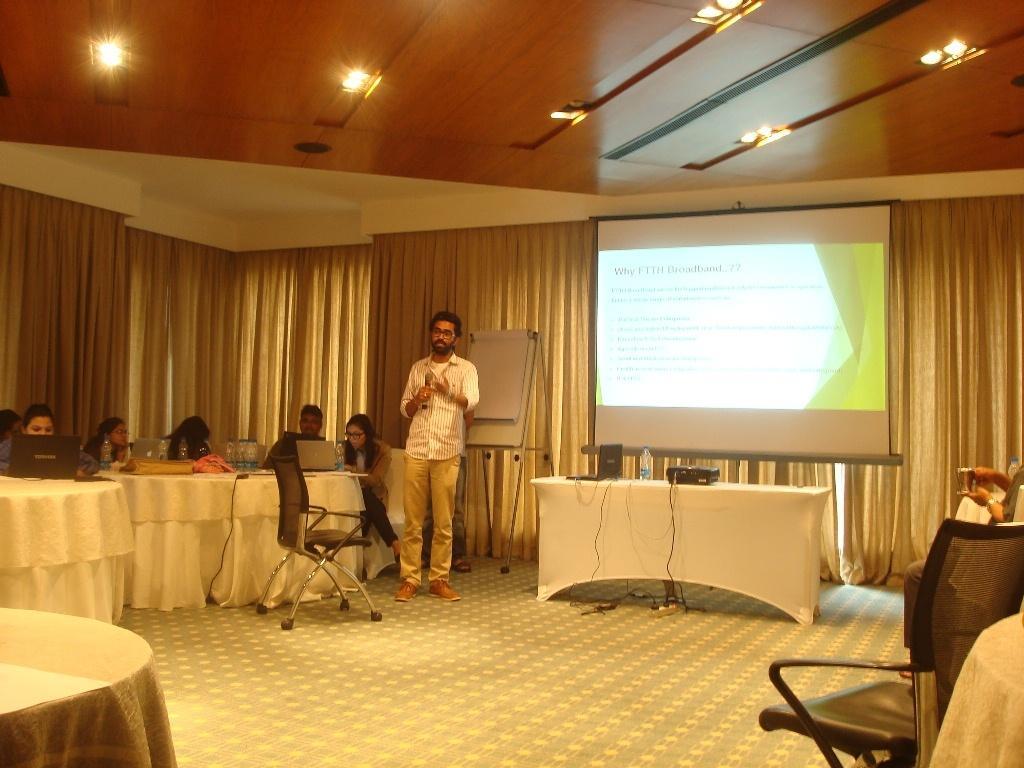In one or two sentences, can you explain what this image depicts? Here we can see a group of members are sitting on the chair, and in front here is the table and laptops and some objects on it, and here is the person standing on the floor, and here is the projector. 